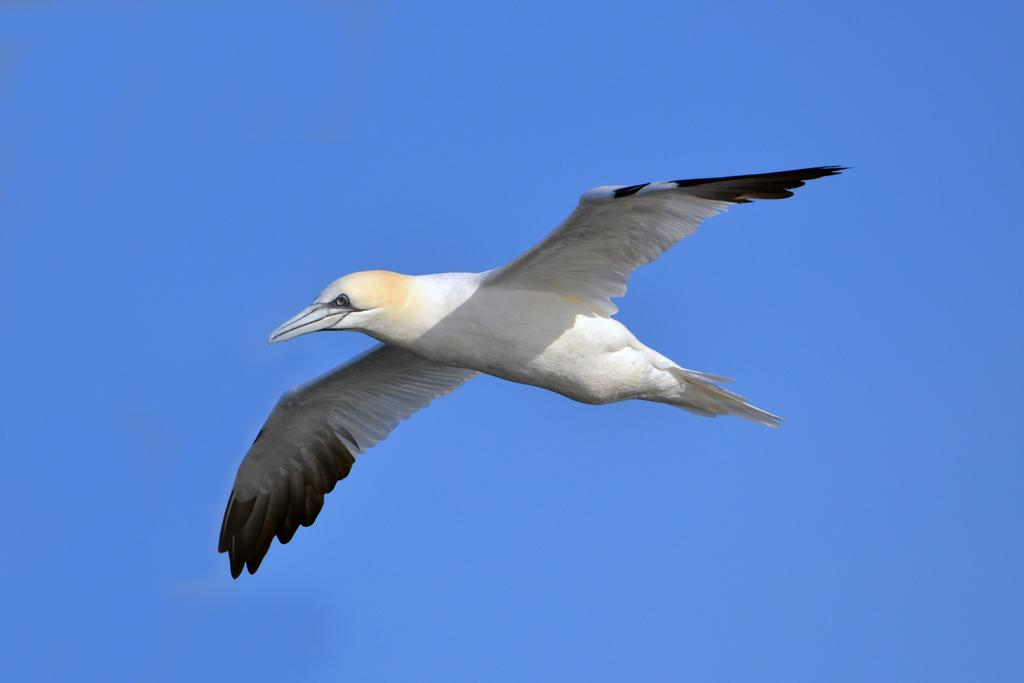What is the main subject of the image? The main subject of the image is a bird flying in the air. Can you describe the bird's activity in the image? The bird is flying in the air. What can be seen in the background of the image? The sky is visible in the background of the image, and it is clear and blue. What type of joke is the bird telling in the image? There is no indication in the image that the bird is telling a joke, as birds do not have the ability to tell jokes. 